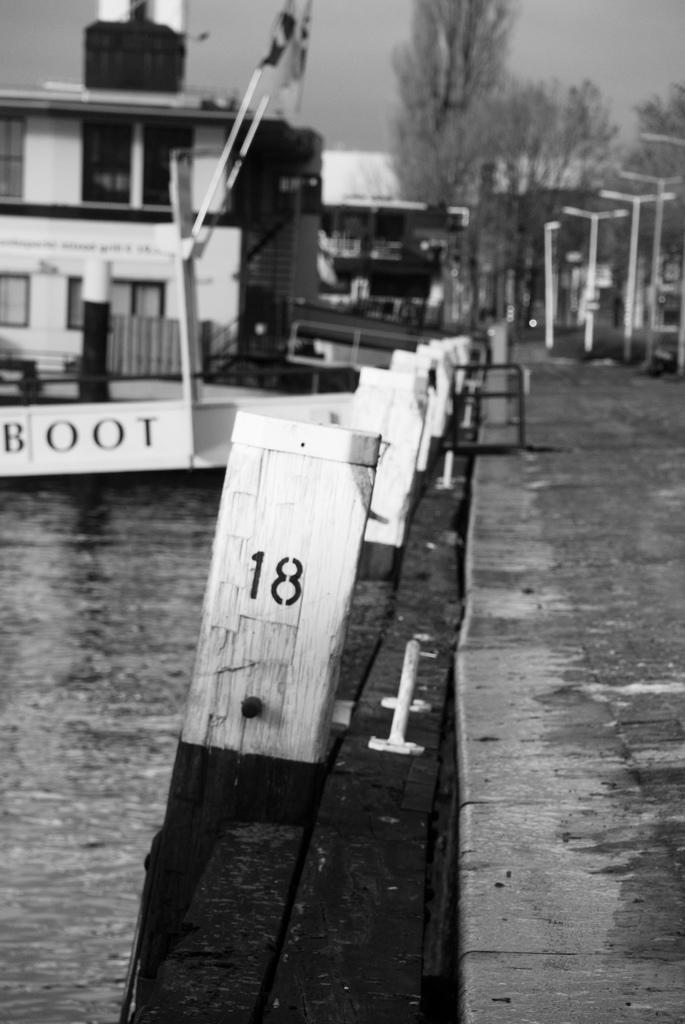Describe this image in one or two sentences. In this image we can see a boat in a water body. We can also see some poles, a group of trees, a building and the sky. 